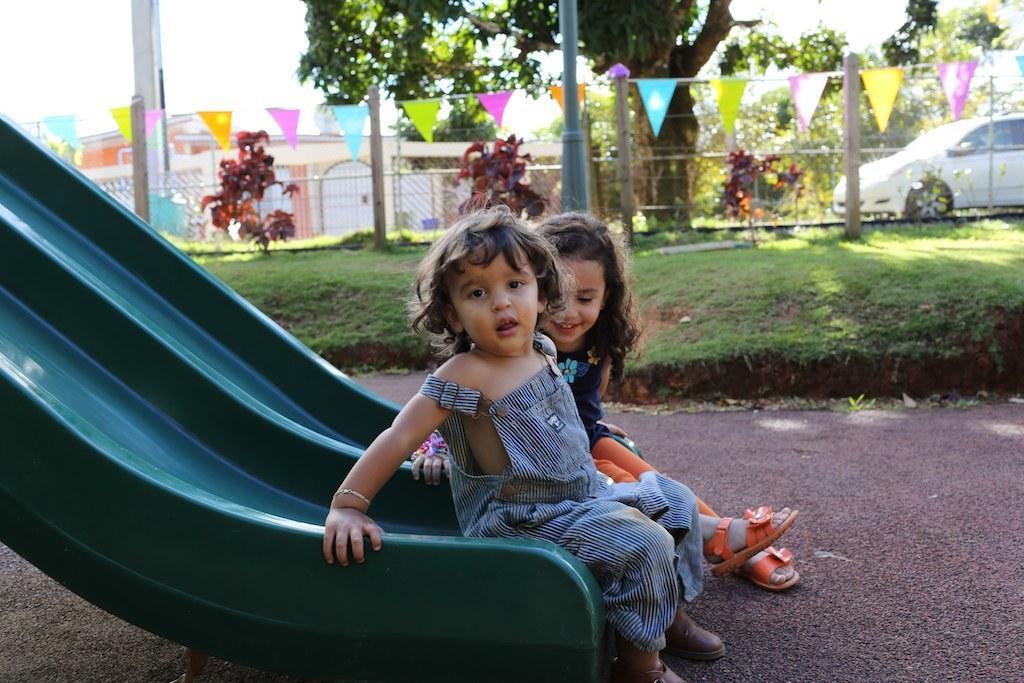Could you give a brief overview of what you see in this image? In the picture we can see two kids sitting on slider, there is grass and in the background of the picture there are some trees, houses, car which is parked and there is clear sky. 